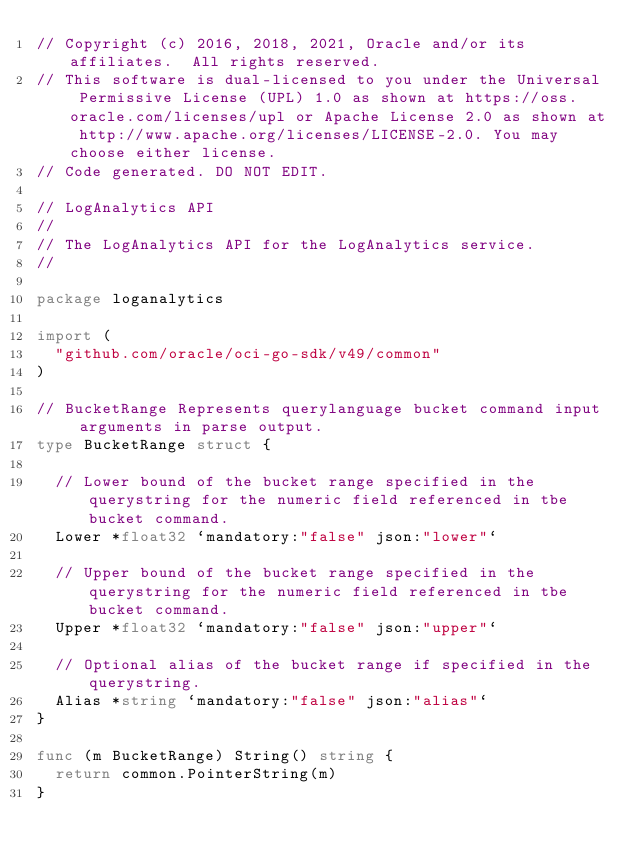Convert code to text. <code><loc_0><loc_0><loc_500><loc_500><_Go_>// Copyright (c) 2016, 2018, 2021, Oracle and/or its affiliates.  All rights reserved.
// This software is dual-licensed to you under the Universal Permissive License (UPL) 1.0 as shown at https://oss.oracle.com/licenses/upl or Apache License 2.0 as shown at http://www.apache.org/licenses/LICENSE-2.0. You may choose either license.
// Code generated. DO NOT EDIT.

// LogAnalytics API
//
// The LogAnalytics API for the LogAnalytics service.
//

package loganalytics

import (
	"github.com/oracle/oci-go-sdk/v49/common"
)

// BucketRange Represents querylanguage bucket command input arguments in parse output.
type BucketRange struct {

	// Lower bound of the bucket range specified in the querystring for the numeric field referenced in tbe bucket command.
	Lower *float32 `mandatory:"false" json:"lower"`

	// Upper bound of the bucket range specified in the querystring for the numeric field referenced in tbe bucket command.
	Upper *float32 `mandatory:"false" json:"upper"`

	// Optional alias of the bucket range if specified in the querystring.
	Alias *string `mandatory:"false" json:"alias"`
}

func (m BucketRange) String() string {
	return common.PointerString(m)
}
</code> 